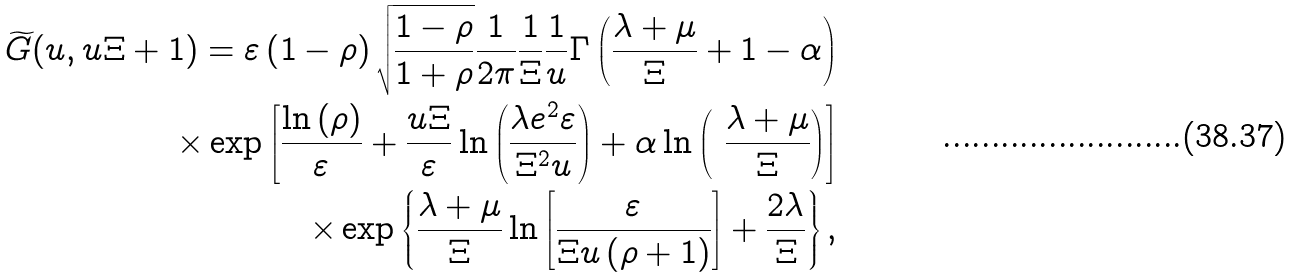<formula> <loc_0><loc_0><loc_500><loc_500>\widetilde { G } ( u , u \Xi + 1 ) = \varepsilon \left ( 1 - \rho \right ) \sqrt { \frac { 1 - \rho } { 1 + \rho } } \frac { 1 } { 2 \pi } \frac { 1 } { \Xi } \frac { 1 } { u } \Gamma \left ( \frac { \lambda + \mu } { \Xi } + 1 - \alpha \right ) \\ \times \exp \left [ \frac { \ln \left ( \rho \right ) } { \varepsilon } + \frac { u \Xi } { \varepsilon } \ln \left ( \frac { \lambda e ^ { 2 } \varepsilon } { \Xi ^ { 2 } u } \right ) + \alpha \ln \left ( \ \frac { \lambda + \mu } { \Xi } \right ) \right ] \\ \times \exp \left \{ \frac { \lambda + \mu } { \Xi } \ln \left [ \frac { \varepsilon } { \Xi u \left ( \rho + 1 \right ) } \right ] + \frac { 2 \lambda } { \Xi } \right \} ,</formula> 